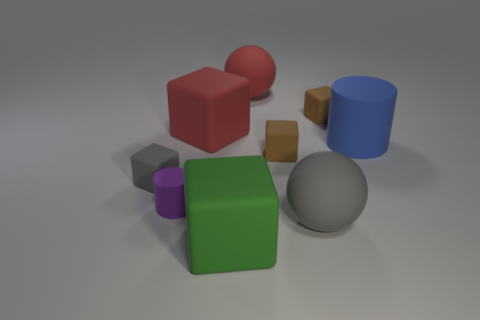How many blocks are either small purple rubber things or small blue shiny objects?
Your answer should be compact. 0. There is a sphere that is right of the rubber sphere that is behind the big red rubber object that is in front of the red ball; how big is it?
Offer a very short reply. Large. Are there any tiny rubber cubes in front of the large gray rubber object?
Give a very brief answer. No. What number of things are big rubber things that are left of the large green object or tiny gray rubber balls?
Make the answer very short. 1. The red block that is the same material as the blue cylinder is what size?
Keep it short and to the point. Large. Do the blue rubber thing and the gray matte object right of the purple thing have the same size?
Offer a terse response. Yes. What is the color of the small object that is on the left side of the red sphere and behind the small purple cylinder?
Offer a terse response. Gray. How many things are tiny matte blocks right of the red rubber sphere or small blocks in front of the large blue thing?
Your answer should be compact. 3. The big rubber ball in front of the small object that is left of the cylinder left of the green cube is what color?
Your answer should be very brief. Gray. Are there any other gray rubber things that have the same shape as the tiny gray object?
Your answer should be very brief. No. 